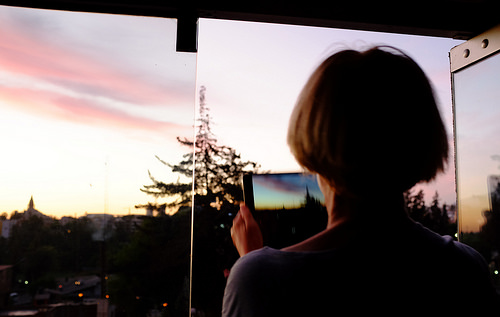<image>
Can you confirm if the girl is next to the sky? No. The girl is not positioned next to the sky. They are located in different areas of the scene. 